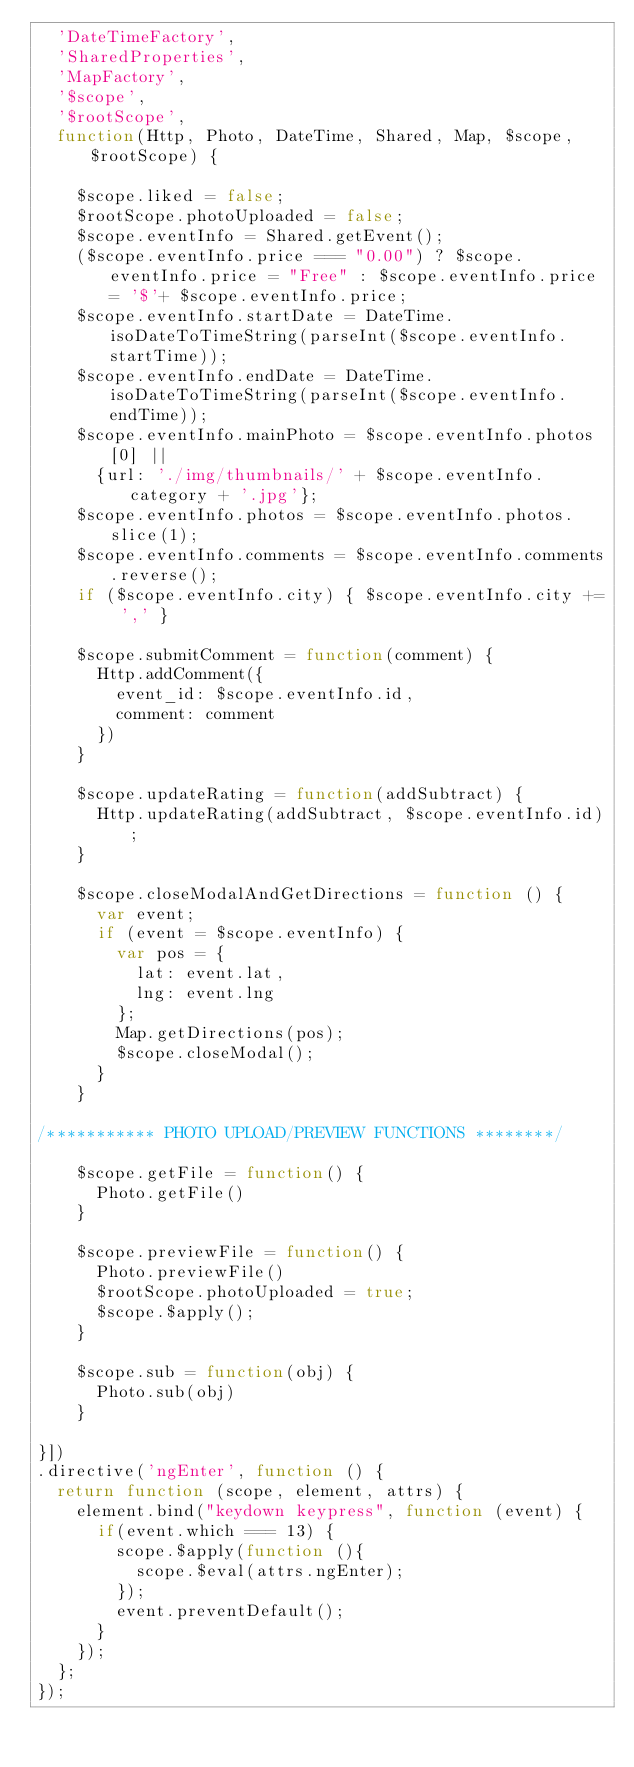Convert code to text. <code><loc_0><loc_0><loc_500><loc_500><_JavaScript_>  'DateTimeFactory',
  'SharedProperties',
  'MapFactory',
  '$scope',
  '$rootScope',
  function(Http, Photo, DateTime, Shared, Map, $scope, $rootScope) {

    $scope.liked = false;
    $rootScope.photoUploaded = false;
    $scope.eventInfo = Shared.getEvent();
    ($scope.eventInfo.price === "0.00") ? $scope.eventInfo.price = "Free" : $scope.eventInfo.price = '$'+ $scope.eventInfo.price;
    $scope.eventInfo.startDate = DateTime.isoDateToTimeString(parseInt($scope.eventInfo.startTime));
    $scope.eventInfo.endDate = DateTime.isoDateToTimeString(parseInt($scope.eventInfo.endTime));
    $scope.eventInfo.mainPhoto = $scope.eventInfo.photos[0] || 
      {url: './img/thumbnails/' + $scope.eventInfo.category + '.jpg'};
    $scope.eventInfo.photos = $scope.eventInfo.photos.slice(1);
    $scope.eventInfo.comments = $scope.eventInfo.comments.reverse();
    if ($scope.eventInfo.city) { $scope.eventInfo.city += ',' }

    $scope.submitComment = function(comment) {
      Http.addComment({
        event_id: $scope.eventInfo.id,
        comment: comment
      })
    }
    
    $scope.updateRating = function(addSubtract) {
      Http.updateRating(addSubtract, $scope.eventInfo.id);
    }

    $scope.closeModalAndGetDirections = function () {
      var event;
      if (event = $scope.eventInfo) {
        var pos = {
          lat: event.lat,
          lng: event.lng
        };
        Map.getDirections(pos);
        $scope.closeModal();
      }
    }

/*********** PHOTO UPLOAD/PREVIEW FUNCTIONS ********/

    $scope.getFile = function() {
      Photo.getFile()
    }

    $scope.previewFile = function() {
      Photo.previewFile()
      $rootScope.photoUploaded = true;
      $scope.$apply();
    }

    $scope.sub = function(obj) {
      Photo.sub(obj)
    }

}])
.directive('ngEnter', function () {
  return function (scope, element, attrs) {
    element.bind("keydown keypress", function (event) {
      if(event.which === 13) {
        scope.$apply(function (){
          scope.$eval(attrs.ngEnter);
        });
        event.preventDefault();
      }
    });
  };
});</code> 